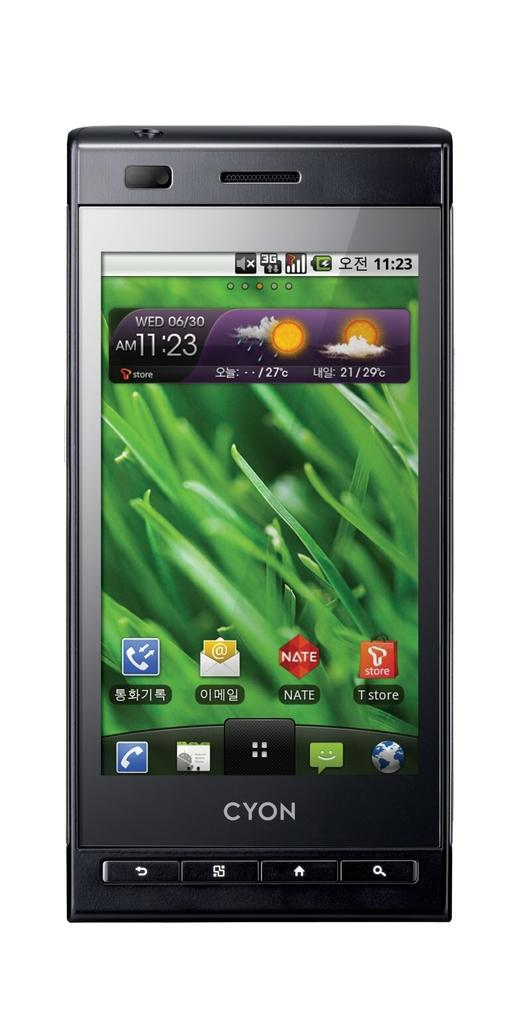Provide a one-sentence caption for the provided image. A cellphone by Cyon is turned on and displays the desktop with the weather and various application icons. 